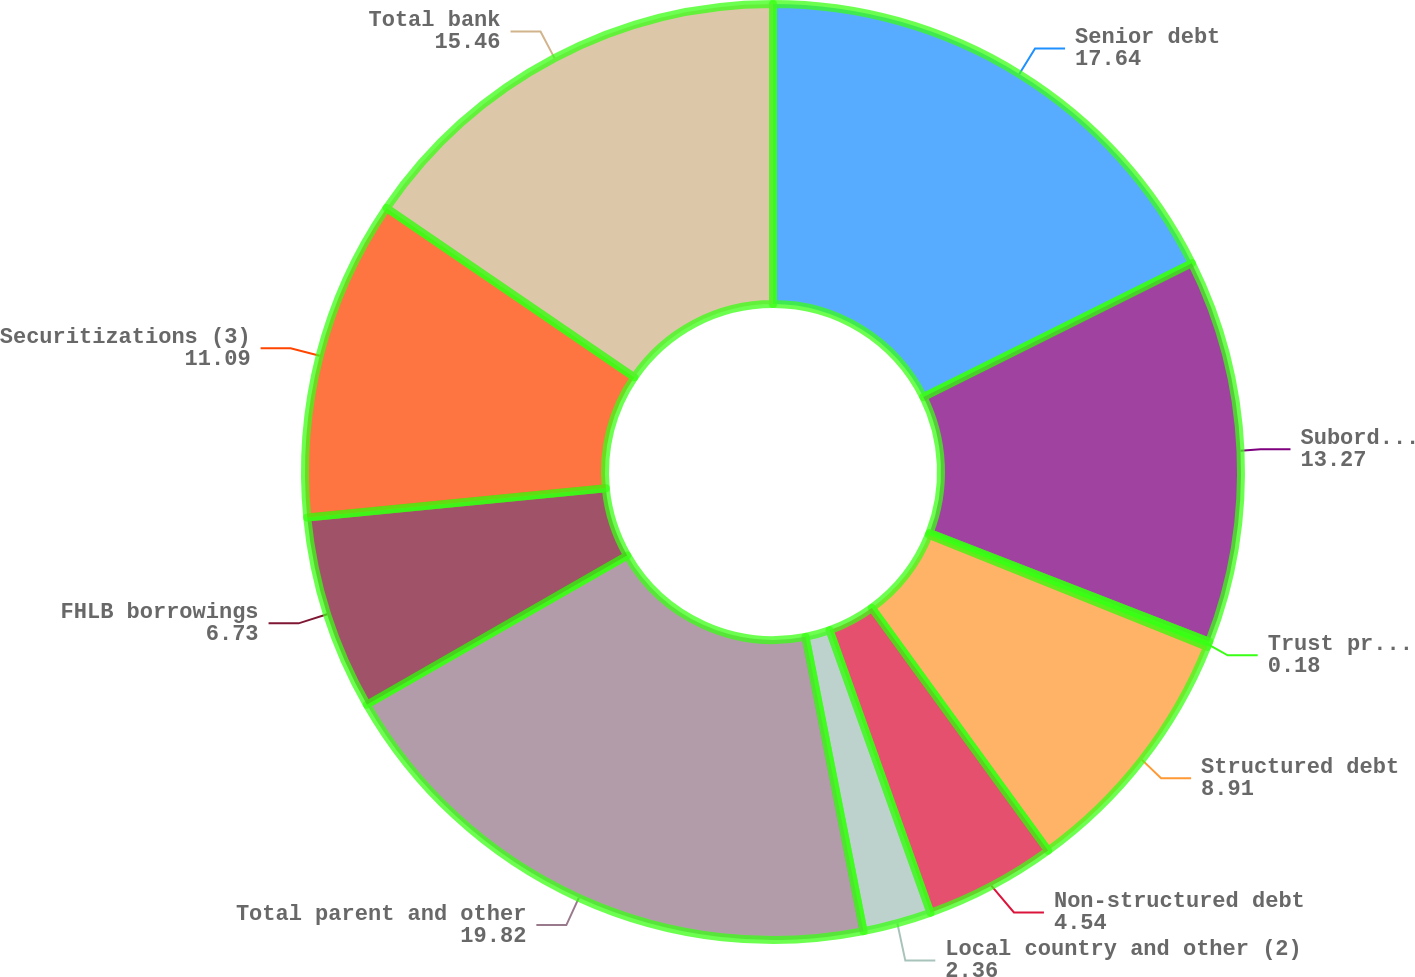Convert chart. <chart><loc_0><loc_0><loc_500><loc_500><pie_chart><fcel>Senior debt<fcel>Subordinated debt<fcel>Trust preferred<fcel>Structured debt<fcel>Non-structured debt<fcel>Local country and other (2)<fcel>Total parent and other<fcel>FHLB borrowings<fcel>Securitizations (3)<fcel>Total bank<nl><fcel>17.64%<fcel>13.27%<fcel>0.18%<fcel>8.91%<fcel>4.54%<fcel>2.36%<fcel>19.82%<fcel>6.73%<fcel>11.09%<fcel>15.46%<nl></chart> 